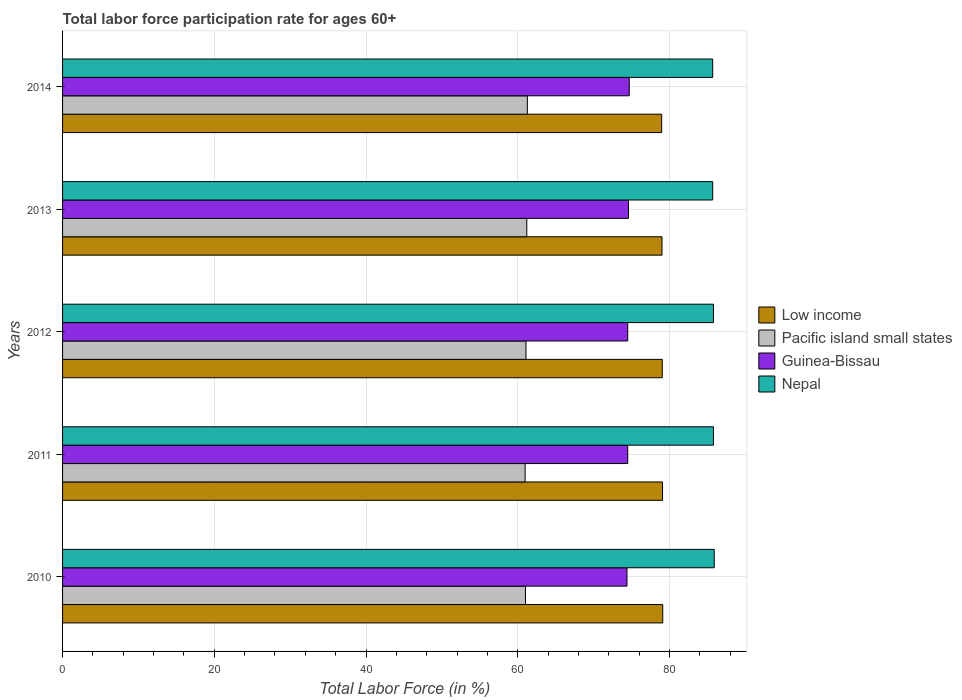How many bars are there on the 1st tick from the top?
Ensure brevity in your answer.  4. How many bars are there on the 4th tick from the bottom?
Your answer should be very brief. 4. What is the label of the 5th group of bars from the top?
Offer a terse response. 2010. What is the labor force participation rate in Nepal in 2011?
Your answer should be very brief. 85.8. Across all years, what is the maximum labor force participation rate in Guinea-Bissau?
Your answer should be compact. 74.7. Across all years, what is the minimum labor force participation rate in Pacific island small states?
Keep it short and to the point. 60.97. In which year was the labor force participation rate in Low income maximum?
Ensure brevity in your answer.  2010. What is the total labor force participation rate in Pacific island small states in the graph?
Your answer should be compact. 305.54. What is the difference between the labor force participation rate in Nepal in 2010 and that in 2012?
Keep it short and to the point. 0.1. What is the difference between the labor force participation rate in Low income in 2010 and the labor force participation rate in Nepal in 2014?
Keep it short and to the point. -6.59. What is the average labor force participation rate in Guinea-Bissau per year?
Offer a very short reply. 74.54. In the year 2010, what is the difference between the labor force participation rate in Nepal and labor force participation rate in Pacific island small states?
Your response must be concise. 24.88. What is the ratio of the labor force participation rate in Pacific island small states in 2011 to that in 2012?
Your answer should be compact. 1. Is the difference between the labor force participation rate in Nepal in 2011 and 2013 greater than the difference between the labor force participation rate in Pacific island small states in 2011 and 2013?
Ensure brevity in your answer.  Yes. What is the difference between the highest and the second highest labor force participation rate in Guinea-Bissau?
Your response must be concise. 0.1. What is the difference between the highest and the lowest labor force participation rate in Low income?
Keep it short and to the point. 0.14. Is it the case that in every year, the sum of the labor force participation rate in Pacific island small states and labor force participation rate in Nepal is greater than the sum of labor force participation rate in Low income and labor force participation rate in Guinea-Bissau?
Offer a very short reply. Yes. What does the 3rd bar from the top in 2013 represents?
Make the answer very short. Pacific island small states. What does the 2nd bar from the bottom in 2014 represents?
Offer a very short reply. Pacific island small states. Is it the case that in every year, the sum of the labor force participation rate in Pacific island small states and labor force participation rate in Guinea-Bissau is greater than the labor force participation rate in Nepal?
Provide a succinct answer. Yes. How many bars are there?
Give a very brief answer. 20. Are all the bars in the graph horizontal?
Give a very brief answer. Yes. How many years are there in the graph?
Give a very brief answer. 5. Where does the legend appear in the graph?
Offer a terse response. Center right. What is the title of the graph?
Make the answer very short. Total labor force participation rate for ages 60+. What is the Total Labor Force (in %) of Low income in 2010?
Provide a short and direct response. 79.11. What is the Total Labor Force (in %) in Pacific island small states in 2010?
Offer a terse response. 61.02. What is the Total Labor Force (in %) in Guinea-Bissau in 2010?
Provide a short and direct response. 74.4. What is the Total Labor Force (in %) in Nepal in 2010?
Give a very brief answer. 85.9. What is the Total Labor Force (in %) of Low income in 2011?
Make the answer very short. 79.09. What is the Total Labor Force (in %) of Pacific island small states in 2011?
Your answer should be very brief. 60.97. What is the Total Labor Force (in %) in Guinea-Bissau in 2011?
Make the answer very short. 74.5. What is the Total Labor Force (in %) in Nepal in 2011?
Ensure brevity in your answer.  85.8. What is the Total Labor Force (in %) in Low income in 2012?
Give a very brief answer. 79.06. What is the Total Labor Force (in %) in Pacific island small states in 2012?
Your answer should be very brief. 61.09. What is the Total Labor Force (in %) in Guinea-Bissau in 2012?
Keep it short and to the point. 74.5. What is the Total Labor Force (in %) of Nepal in 2012?
Keep it short and to the point. 85.8. What is the Total Labor Force (in %) of Low income in 2013?
Keep it short and to the point. 79.02. What is the Total Labor Force (in %) in Pacific island small states in 2013?
Provide a short and direct response. 61.19. What is the Total Labor Force (in %) in Guinea-Bissau in 2013?
Make the answer very short. 74.6. What is the Total Labor Force (in %) in Nepal in 2013?
Give a very brief answer. 85.7. What is the Total Labor Force (in %) in Low income in 2014?
Offer a very short reply. 78.98. What is the Total Labor Force (in %) in Pacific island small states in 2014?
Your response must be concise. 61.27. What is the Total Labor Force (in %) of Guinea-Bissau in 2014?
Offer a terse response. 74.7. What is the Total Labor Force (in %) in Nepal in 2014?
Give a very brief answer. 85.7. Across all years, what is the maximum Total Labor Force (in %) of Low income?
Provide a short and direct response. 79.11. Across all years, what is the maximum Total Labor Force (in %) in Pacific island small states?
Keep it short and to the point. 61.27. Across all years, what is the maximum Total Labor Force (in %) of Guinea-Bissau?
Offer a very short reply. 74.7. Across all years, what is the maximum Total Labor Force (in %) of Nepal?
Provide a short and direct response. 85.9. Across all years, what is the minimum Total Labor Force (in %) in Low income?
Your answer should be very brief. 78.98. Across all years, what is the minimum Total Labor Force (in %) of Pacific island small states?
Ensure brevity in your answer.  60.97. Across all years, what is the minimum Total Labor Force (in %) in Guinea-Bissau?
Provide a succinct answer. 74.4. Across all years, what is the minimum Total Labor Force (in %) in Nepal?
Provide a succinct answer. 85.7. What is the total Total Labor Force (in %) of Low income in the graph?
Provide a short and direct response. 395.25. What is the total Total Labor Force (in %) of Pacific island small states in the graph?
Keep it short and to the point. 305.54. What is the total Total Labor Force (in %) of Guinea-Bissau in the graph?
Your answer should be compact. 372.7. What is the total Total Labor Force (in %) in Nepal in the graph?
Your answer should be compact. 428.9. What is the difference between the Total Labor Force (in %) of Low income in 2010 and that in 2011?
Give a very brief answer. 0.03. What is the difference between the Total Labor Force (in %) in Pacific island small states in 2010 and that in 2011?
Provide a short and direct response. 0.05. What is the difference between the Total Labor Force (in %) in Nepal in 2010 and that in 2011?
Offer a terse response. 0.1. What is the difference between the Total Labor Force (in %) of Low income in 2010 and that in 2012?
Your answer should be compact. 0.06. What is the difference between the Total Labor Force (in %) in Pacific island small states in 2010 and that in 2012?
Provide a short and direct response. -0.06. What is the difference between the Total Labor Force (in %) of Nepal in 2010 and that in 2012?
Your response must be concise. 0.1. What is the difference between the Total Labor Force (in %) in Low income in 2010 and that in 2013?
Give a very brief answer. 0.1. What is the difference between the Total Labor Force (in %) of Pacific island small states in 2010 and that in 2013?
Your answer should be compact. -0.17. What is the difference between the Total Labor Force (in %) in Guinea-Bissau in 2010 and that in 2013?
Your answer should be very brief. -0.2. What is the difference between the Total Labor Force (in %) in Nepal in 2010 and that in 2013?
Give a very brief answer. 0.2. What is the difference between the Total Labor Force (in %) of Low income in 2010 and that in 2014?
Your answer should be very brief. 0.14. What is the difference between the Total Labor Force (in %) in Pacific island small states in 2010 and that in 2014?
Ensure brevity in your answer.  -0.25. What is the difference between the Total Labor Force (in %) in Guinea-Bissau in 2010 and that in 2014?
Provide a short and direct response. -0.3. What is the difference between the Total Labor Force (in %) in Nepal in 2010 and that in 2014?
Your answer should be very brief. 0.2. What is the difference between the Total Labor Force (in %) in Low income in 2011 and that in 2012?
Your answer should be compact. 0.03. What is the difference between the Total Labor Force (in %) of Pacific island small states in 2011 and that in 2012?
Ensure brevity in your answer.  -0.11. What is the difference between the Total Labor Force (in %) in Low income in 2011 and that in 2013?
Provide a short and direct response. 0.07. What is the difference between the Total Labor Force (in %) of Pacific island small states in 2011 and that in 2013?
Offer a terse response. -0.22. What is the difference between the Total Labor Force (in %) in Guinea-Bissau in 2011 and that in 2013?
Offer a terse response. -0.1. What is the difference between the Total Labor Force (in %) in Nepal in 2011 and that in 2013?
Your answer should be very brief. 0.1. What is the difference between the Total Labor Force (in %) in Low income in 2011 and that in 2014?
Make the answer very short. 0.11. What is the difference between the Total Labor Force (in %) in Pacific island small states in 2011 and that in 2014?
Your answer should be compact. -0.29. What is the difference between the Total Labor Force (in %) of Nepal in 2011 and that in 2014?
Ensure brevity in your answer.  0.1. What is the difference between the Total Labor Force (in %) of Low income in 2012 and that in 2013?
Make the answer very short. 0.04. What is the difference between the Total Labor Force (in %) of Pacific island small states in 2012 and that in 2013?
Give a very brief answer. -0.11. What is the difference between the Total Labor Force (in %) in Nepal in 2012 and that in 2013?
Keep it short and to the point. 0.1. What is the difference between the Total Labor Force (in %) in Low income in 2012 and that in 2014?
Make the answer very short. 0.08. What is the difference between the Total Labor Force (in %) in Pacific island small states in 2012 and that in 2014?
Keep it short and to the point. -0.18. What is the difference between the Total Labor Force (in %) of Guinea-Bissau in 2012 and that in 2014?
Give a very brief answer. -0.2. What is the difference between the Total Labor Force (in %) in Low income in 2013 and that in 2014?
Offer a terse response. 0.04. What is the difference between the Total Labor Force (in %) of Pacific island small states in 2013 and that in 2014?
Your answer should be very brief. -0.07. What is the difference between the Total Labor Force (in %) in Low income in 2010 and the Total Labor Force (in %) in Pacific island small states in 2011?
Your answer should be compact. 18.14. What is the difference between the Total Labor Force (in %) in Low income in 2010 and the Total Labor Force (in %) in Guinea-Bissau in 2011?
Provide a short and direct response. 4.61. What is the difference between the Total Labor Force (in %) in Low income in 2010 and the Total Labor Force (in %) in Nepal in 2011?
Offer a terse response. -6.69. What is the difference between the Total Labor Force (in %) in Pacific island small states in 2010 and the Total Labor Force (in %) in Guinea-Bissau in 2011?
Provide a succinct answer. -13.48. What is the difference between the Total Labor Force (in %) of Pacific island small states in 2010 and the Total Labor Force (in %) of Nepal in 2011?
Give a very brief answer. -24.78. What is the difference between the Total Labor Force (in %) in Guinea-Bissau in 2010 and the Total Labor Force (in %) in Nepal in 2011?
Your answer should be very brief. -11.4. What is the difference between the Total Labor Force (in %) in Low income in 2010 and the Total Labor Force (in %) in Pacific island small states in 2012?
Provide a succinct answer. 18.03. What is the difference between the Total Labor Force (in %) of Low income in 2010 and the Total Labor Force (in %) of Guinea-Bissau in 2012?
Keep it short and to the point. 4.61. What is the difference between the Total Labor Force (in %) of Low income in 2010 and the Total Labor Force (in %) of Nepal in 2012?
Ensure brevity in your answer.  -6.69. What is the difference between the Total Labor Force (in %) in Pacific island small states in 2010 and the Total Labor Force (in %) in Guinea-Bissau in 2012?
Provide a succinct answer. -13.48. What is the difference between the Total Labor Force (in %) in Pacific island small states in 2010 and the Total Labor Force (in %) in Nepal in 2012?
Give a very brief answer. -24.78. What is the difference between the Total Labor Force (in %) in Low income in 2010 and the Total Labor Force (in %) in Pacific island small states in 2013?
Your answer should be compact. 17.92. What is the difference between the Total Labor Force (in %) in Low income in 2010 and the Total Labor Force (in %) in Guinea-Bissau in 2013?
Provide a succinct answer. 4.51. What is the difference between the Total Labor Force (in %) in Low income in 2010 and the Total Labor Force (in %) in Nepal in 2013?
Your answer should be very brief. -6.59. What is the difference between the Total Labor Force (in %) of Pacific island small states in 2010 and the Total Labor Force (in %) of Guinea-Bissau in 2013?
Make the answer very short. -13.58. What is the difference between the Total Labor Force (in %) in Pacific island small states in 2010 and the Total Labor Force (in %) in Nepal in 2013?
Your response must be concise. -24.68. What is the difference between the Total Labor Force (in %) in Guinea-Bissau in 2010 and the Total Labor Force (in %) in Nepal in 2013?
Your answer should be compact. -11.3. What is the difference between the Total Labor Force (in %) of Low income in 2010 and the Total Labor Force (in %) of Pacific island small states in 2014?
Offer a terse response. 17.85. What is the difference between the Total Labor Force (in %) of Low income in 2010 and the Total Labor Force (in %) of Guinea-Bissau in 2014?
Ensure brevity in your answer.  4.41. What is the difference between the Total Labor Force (in %) of Low income in 2010 and the Total Labor Force (in %) of Nepal in 2014?
Give a very brief answer. -6.59. What is the difference between the Total Labor Force (in %) of Pacific island small states in 2010 and the Total Labor Force (in %) of Guinea-Bissau in 2014?
Your response must be concise. -13.68. What is the difference between the Total Labor Force (in %) of Pacific island small states in 2010 and the Total Labor Force (in %) of Nepal in 2014?
Offer a terse response. -24.68. What is the difference between the Total Labor Force (in %) in Guinea-Bissau in 2010 and the Total Labor Force (in %) in Nepal in 2014?
Your answer should be very brief. -11.3. What is the difference between the Total Labor Force (in %) of Low income in 2011 and the Total Labor Force (in %) of Pacific island small states in 2012?
Your answer should be very brief. 18. What is the difference between the Total Labor Force (in %) of Low income in 2011 and the Total Labor Force (in %) of Guinea-Bissau in 2012?
Your response must be concise. 4.59. What is the difference between the Total Labor Force (in %) of Low income in 2011 and the Total Labor Force (in %) of Nepal in 2012?
Offer a very short reply. -6.71. What is the difference between the Total Labor Force (in %) of Pacific island small states in 2011 and the Total Labor Force (in %) of Guinea-Bissau in 2012?
Your response must be concise. -13.53. What is the difference between the Total Labor Force (in %) in Pacific island small states in 2011 and the Total Labor Force (in %) in Nepal in 2012?
Provide a succinct answer. -24.83. What is the difference between the Total Labor Force (in %) of Guinea-Bissau in 2011 and the Total Labor Force (in %) of Nepal in 2012?
Make the answer very short. -11.3. What is the difference between the Total Labor Force (in %) in Low income in 2011 and the Total Labor Force (in %) in Pacific island small states in 2013?
Make the answer very short. 17.89. What is the difference between the Total Labor Force (in %) of Low income in 2011 and the Total Labor Force (in %) of Guinea-Bissau in 2013?
Offer a terse response. 4.49. What is the difference between the Total Labor Force (in %) in Low income in 2011 and the Total Labor Force (in %) in Nepal in 2013?
Provide a short and direct response. -6.61. What is the difference between the Total Labor Force (in %) in Pacific island small states in 2011 and the Total Labor Force (in %) in Guinea-Bissau in 2013?
Offer a terse response. -13.63. What is the difference between the Total Labor Force (in %) in Pacific island small states in 2011 and the Total Labor Force (in %) in Nepal in 2013?
Provide a short and direct response. -24.73. What is the difference between the Total Labor Force (in %) in Guinea-Bissau in 2011 and the Total Labor Force (in %) in Nepal in 2013?
Provide a short and direct response. -11.2. What is the difference between the Total Labor Force (in %) of Low income in 2011 and the Total Labor Force (in %) of Pacific island small states in 2014?
Your answer should be very brief. 17.82. What is the difference between the Total Labor Force (in %) in Low income in 2011 and the Total Labor Force (in %) in Guinea-Bissau in 2014?
Your response must be concise. 4.39. What is the difference between the Total Labor Force (in %) in Low income in 2011 and the Total Labor Force (in %) in Nepal in 2014?
Provide a short and direct response. -6.61. What is the difference between the Total Labor Force (in %) of Pacific island small states in 2011 and the Total Labor Force (in %) of Guinea-Bissau in 2014?
Offer a very short reply. -13.73. What is the difference between the Total Labor Force (in %) in Pacific island small states in 2011 and the Total Labor Force (in %) in Nepal in 2014?
Ensure brevity in your answer.  -24.73. What is the difference between the Total Labor Force (in %) in Low income in 2012 and the Total Labor Force (in %) in Pacific island small states in 2013?
Ensure brevity in your answer.  17.86. What is the difference between the Total Labor Force (in %) of Low income in 2012 and the Total Labor Force (in %) of Guinea-Bissau in 2013?
Provide a short and direct response. 4.46. What is the difference between the Total Labor Force (in %) in Low income in 2012 and the Total Labor Force (in %) in Nepal in 2013?
Your answer should be compact. -6.64. What is the difference between the Total Labor Force (in %) of Pacific island small states in 2012 and the Total Labor Force (in %) of Guinea-Bissau in 2013?
Your answer should be very brief. -13.51. What is the difference between the Total Labor Force (in %) of Pacific island small states in 2012 and the Total Labor Force (in %) of Nepal in 2013?
Provide a succinct answer. -24.61. What is the difference between the Total Labor Force (in %) in Low income in 2012 and the Total Labor Force (in %) in Pacific island small states in 2014?
Offer a terse response. 17.79. What is the difference between the Total Labor Force (in %) in Low income in 2012 and the Total Labor Force (in %) in Guinea-Bissau in 2014?
Give a very brief answer. 4.36. What is the difference between the Total Labor Force (in %) in Low income in 2012 and the Total Labor Force (in %) in Nepal in 2014?
Your answer should be very brief. -6.64. What is the difference between the Total Labor Force (in %) of Pacific island small states in 2012 and the Total Labor Force (in %) of Guinea-Bissau in 2014?
Make the answer very short. -13.61. What is the difference between the Total Labor Force (in %) of Pacific island small states in 2012 and the Total Labor Force (in %) of Nepal in 2014?
Provide a short and direct response. -24.61. What is the difference between the Total Labor Force (in %) of Low income in 2013 and the Total Labor Force (in %) of Pacific island small states in 2014?
Your answer should be very brief. 17.75. What is the difference between the Total Labor Force (in %) of Low income in 2013 and the Total Labor Force (in %) of Guinea-Bissau in 2014?
Offer a terse response. 4.32. What is the difference between the Total Labor Force (in %) in Low income in 2013 and the Total Labor Force (in %) in Nepal in 2014?
Provide a succinct answer. -6.68. What is the difference between the Total Labor Force (in %) in Pacific island small states in 2013 and the Total Labor Force (in %) in Guinea-Bissau in 2014?
Ensure brevity in your answer.  -13.51. What is the difference between the Total Labor Force (in %) of Pacific island small states in 2013 and the Total Labor Force (in %) of Nepal in 2014?
Keep it short and to the point. -24.51. What is the difference between the Total Labor Force (in %) in Guinea-Bissau in 2013 and the Total Labor Force (in %) in Nepal in 2014?
Make the answer very short. -11.1. What is the average Total Labor Force (in %) in Low income per year?
Your response must be concise. 79.05. What is the average Total Labor Force (in %) in Pacific island small states per year?
Your answer should be very brief. 61.11. What is the average Total Labor Force (in %) of Guinea-Bissau per year?
Ensure brevity in your answer.  74.54. What is the average Total Labor Force (in %) of Nepal per year?
Offer a very short reply. 85.78. In the year 2010, what is the difference between the Total Labor Force (in %) in Low income and Total Labor Force (in %) in Pacific island small states?
Your answer should be very brief. 18.09. In the year 2010, what is the difference between the Total Labor Force (in %) in Low income and Total Labor Force (in %) in Guinea-Bissau?
Make the answer very short. 4.71. In the year 2010, what is the difference between the Total Labor Force (in %) of Low income and Total Labor Force (in %) of Nepal?
Keep it short and to the point. -6.79. In the year 2010, what is the difference between the Total Labor Force (in %) of Pacific island small states and Total Labor Force (in %) of Guinea-Bissau?
Ensure brevity in your answer.  -13.38. In the year 2010, what is the difference between the Total Labor Force (in %) of Pacific island small states and Total Labor Force (in %) of Nepal?
Your answer should be very brief. -24.88. In the year 2010, what is the difference between the Total Labor Force (in %) in Guinea-Bissau and Total Labor Force (in %) in Nepal?
Ensure brevity in your answer.  -11.5. In the year 2011, what is the difference between the Total Labor Force (in %) of Low income and Total Labor Force (in %) of Pacific island small states?
Provide a short and direct response. 18.11. In the year 2011, what is the difference between the Total Labor Force (in %) in Low income and Total Labor Force (in %) in Guinea-Bissau?
Offer a terse response. 4.59. In the year 2011, what is the difference between the Total Labor Force (in %) in Low income and Total Labor Force (in %) in Nepal?
Offer a very short reply. -6.71. In the year 2011, what is the difference between the Total Labor Force (in %) of Pacific island small states and Total Labor Force (in %) of Guinea-Bissau?
Ensure brevity in your answer.  -13.53. In the year 2011, what is the difference between the Total Labor Force (in %) of Pacific island small states and Total Labor Force (in %) of Nepal?
Provide a short and direct response. -24.83. In the year 2012, what is the difference between the Total Labor Force (in %) in Low income and Total Labor Force (in %) in Pacific island small states?
Your answer should be very brief. 17.97. In the year 2012, what is the difference between the Total Labor Force (in %) in Low income and Total Labor Force (in %) in Guinea-Bissau?
Provide a short and direct response. 4.56. In the year 2012, what is the difference between the Total Labor Force (in %) of Low income and Total Labor Force (in %) of Nepal?
Provide a short and direct response. -6.74. In the year 2012, what is the difference between the Total Labor Force (in %) in Pacific island small states and Total Labor Force (in %) in Guinea-Bissau?
Provide a succinct answer. -13.41. In the year 2012, what is the difference between the Total Labor Force (in %) of Pacific island small states and Total Labor Force (in %) of Nepal?
Your answer should be compact. -24.71. In the year 2012, what is the difference between the Total Labor Force (in %) of Guinea-Bissau and Total Labor Force (in %) of Nepal?
Provide a short and direct response. -11.3. In the year 2013, what is the difference between the Total Labor Force (in %) of Low income and Total Labor Force (in %) of Pacific island small states?
Your response must be concise. 17.82. In the year 2013, what is the difference between the Total Labor Force (in %) in Low income and Total Labor Force (in %) in Guinea-Bissau?
Provide a short and direct response. 4.42. In the year 2013, what is the difference between the Total Labor Force (in %) of Low income and Total Labor Force (in %) of Nepal?
Your response must be concise. -6.68. In the year 2013, what is the difference between the Total Labor Force (in %) of Pacific island small states and Total Labor Force (in %) of Guinea-Bissau?
Your answer should be very brief. -13.41. In the year 2013, what is the difference between the Total Labor Force (in %) of Pacific island small states and Total Labor Force (in %) of Nepal?
Provide a short and direct response. -24.51. In the year 2014, what is the difference between the Total Labor Force (in %) of Low income and Total Labor Force (in %) of Pacific island small states?
Your answer should be compact. 17.71. In the year 2014, what is the difference between the Total Labor Force (in %) in Low income and Total Labor Force (in %) in Guinea-Bissau?
Offer a terse response. 4.28. In the year 2014, what is the difference between the Total Labor Force (in %) of Low income and Total Labor Force (in %) of Nepal?
Offer a very short reply. -6.72. In the year 2014, what is the difference between the Total Labor Force (in %) in Pacific island small states and Total Labor Force (in %) in Guinea-Bissau?
Make the answer very short. -13.43. In the year 2014, what is the difference between the Total Labor Force (in %) in Pacific island small states and Total Labor Force (in %) in Nepal?
Offer a terse response. -24.43. In the year 2014, what is the difference between the Total Labor Force (in %) in Guinea-Bissau and Total Labor Force (in %) in Nepal?
Make the answer very short. -11. What is the ratio of the Total Labor Force (in %) in Guinea-Bissau in 2010 to that in 2011?
Your answer should be very brief. 1. What is the ratio of the Total Labor Force (in %) in Guinea-Bissau in 2010 to that in 2012?
Provide a succinct answer. 1. What is the ratio of the Total Labor Force (in %) of Nepal in 2010 to that in 2012?
Offer a terse response. 1. What is the ratio of the Total Labor Force (in %) in Pacific island small states in 2010 to that in 2013?
Provide a short and direct response. 1. What is the ratio of the Total Labor Force (in %) of Guinea-Bissau in 2010 to that in 2014?
Provide a succinct answer. 1. What is the ratio of the Total Labor Force (in %) of Nepal in 2010 to that in 2014?
Ensure brevity in your answer.  1. What is the ratio of the Total Labor Force (in %) in Low income in 2011 to that in 2012?
Give a very brief answer. 1. What is the ratio of the Total Labor Force (in %) in Pacific island small states in 2011 to that in 2012?
Ensure brevity in your answer.  1. What is the ratio of the Total Labor Force (in %) in Guinea-Bissau in 2011 to that in 2012?
Keep it short and to the point. 1. What is the ratio of the Total Labor Force (in %) of Nepal in 2011 to that in 2012?
Your response must be concise. 1. What is the ratio of the Total Labor Force (in %) in Low income in 2011 to that in 2013?
Provide a succinct answer. 1. What is the ratio of the Total Labor Force (in %) of Guinea-Bissau in 2011 to that in 2013?
Give a very brief answer. 1. What is the ratio of the Total Labor Force (in %) of Low income in 2011 to that in 2014?
Your answer should be compact. 1. What is the ratio of the Total Labor Force (in %) of Pacific island small states in 2011 to that in 2014?
Provide a short and direct response. 1. What is the ratio of the Total Labor Force (in %) in Nepal in 2011 to that in 2014?
Make the answer very short. 1. What is the ratio of the Total Labor Force (in %) of Guinea-Bissau in 2012 to that in 2013?
Make the answer very short. 1. What is the ratio of the Total Labor Force (in %) in Nepal in 2012 to that in 2013?
Offer a very short reply. 1. What is the ratio of the Total Labor Force (in %) in Low income in 2012 to that in 2014?
Make the answer very short. 1. What is the ratio of the Total Labor Force (in %) of Guinea-Bissau in 2012 to that in 2014?
Give a very brief answer. 1. What is the ratio of the Total Labor Force (in %) in Nepal in 2012 to that in 2014?
Offer a terse response. 1. What is the ratio of the Total Labor Force (in %) in Pacific island small states in 2013 to that in 2014?
Your answer should be very brief. 1. What is the difference between the highest and the second highest Total Labor Force (in %) of Low income?
Your response must be concise. 0.03. What is the difference between the highest and the second highest Total Labor Force (in %) of Pacific island small states?
Your answer should be very brief. 0.07. What is the difference between the highest and the second highest Total Labor Force (in %) in Guinea-Bissau?
Ensure brevity in your answer.  0.1. What is the difference between the highest and the second highest Total Labor Force (in %) of Nepal?
Offer a terse response. 0.1. What is the difference between the highest and the lowest Total Labor Force (in %) in Low income?
Ensure brevity in your answer.  0.14. What is the difference between the highest and the lowest Total Labor Force (in %) in Pacific island small states?
Give a very brief answer. 0.29. What is the difference between the highest and the lowest Total Labor Force (in %) of Nepal?
Your answer should be compact. 0.2. 